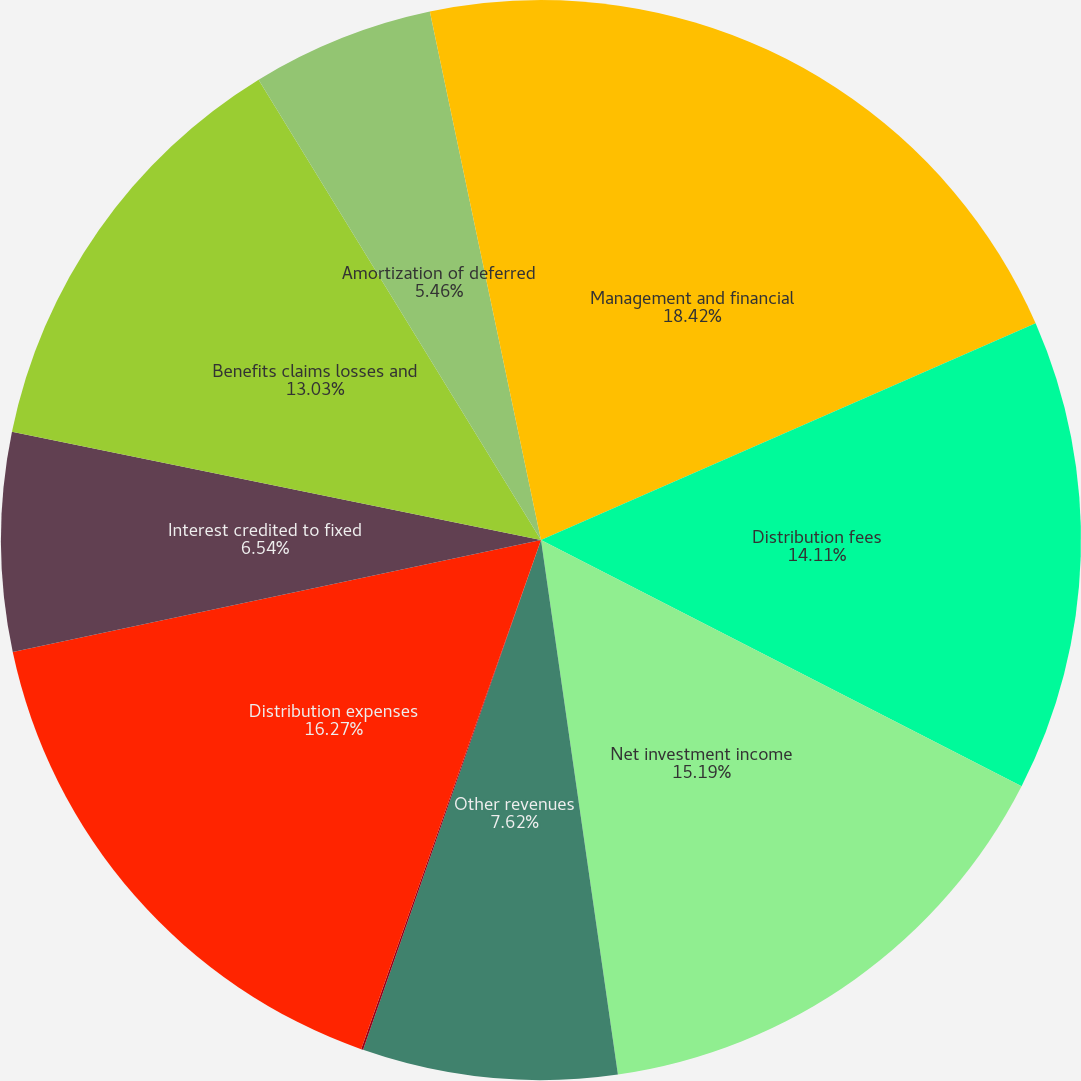Convert chart. <chart><loc_0><loc_0><loc_500><loc_500><pie_chart><fcel>Management and financial<fcel>Distribution fees<fcel>Net investment income<fcel>Other revenues<fcel>Banking and deposit interest<fcel>Distribution expenses<fcel>Interest credited to fixed<fcel>Benefits claims losses and<fcel>Amortization of deferred<fcel>Interest and debt expense<nl><fcel>18.43%<fcel>14.11%<fcel>15.19%<fcel>7.62%<fcel>0.06%<fcel>16.27%<fcel>6.54%<fcel>13.03%<fcel>5.46%<fcel>3.3%<nl></chart> 